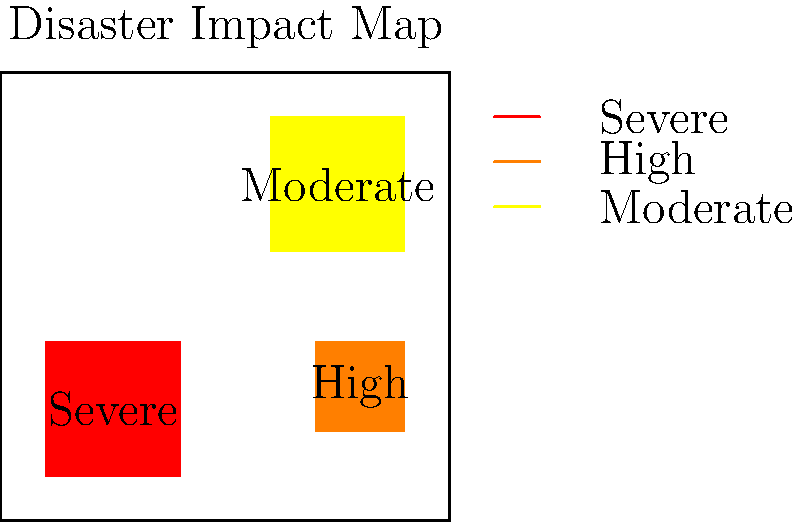Based on the disaster impact map, which severity level covers the largest affected area? To determine which severity level covers the largest affected area, we need to analyze the map and compare the sizes of the colored regions:

1. Identify the severity levels:
   - Red: Severe
   - Orange: High
   - Yellow: Moderate

2. Estimate the relative sizes of each affected area:
   - Severe (red) area: Approximately 30 x 30 = 900 square units
   - High (orange) area: Approximately 20 x 20 = 400 square units
   - Moderate (yellow) area: Approximately 30 x 30 = 900 square units

3. Compare the sizes:
   - The Severe and Moderate areas appear to be equal in size
   - The High severity area is smaller than both Severe and Moderate

4. Conclusion:
   Both Severe and Moderate severity levels cover the largest affected areas, with approximately equal sizes.

Given that the question asks for a single answer, we'll choose "Moderate" as it's alphabetically first among the two equal largest areas.
Answer: Moderate 